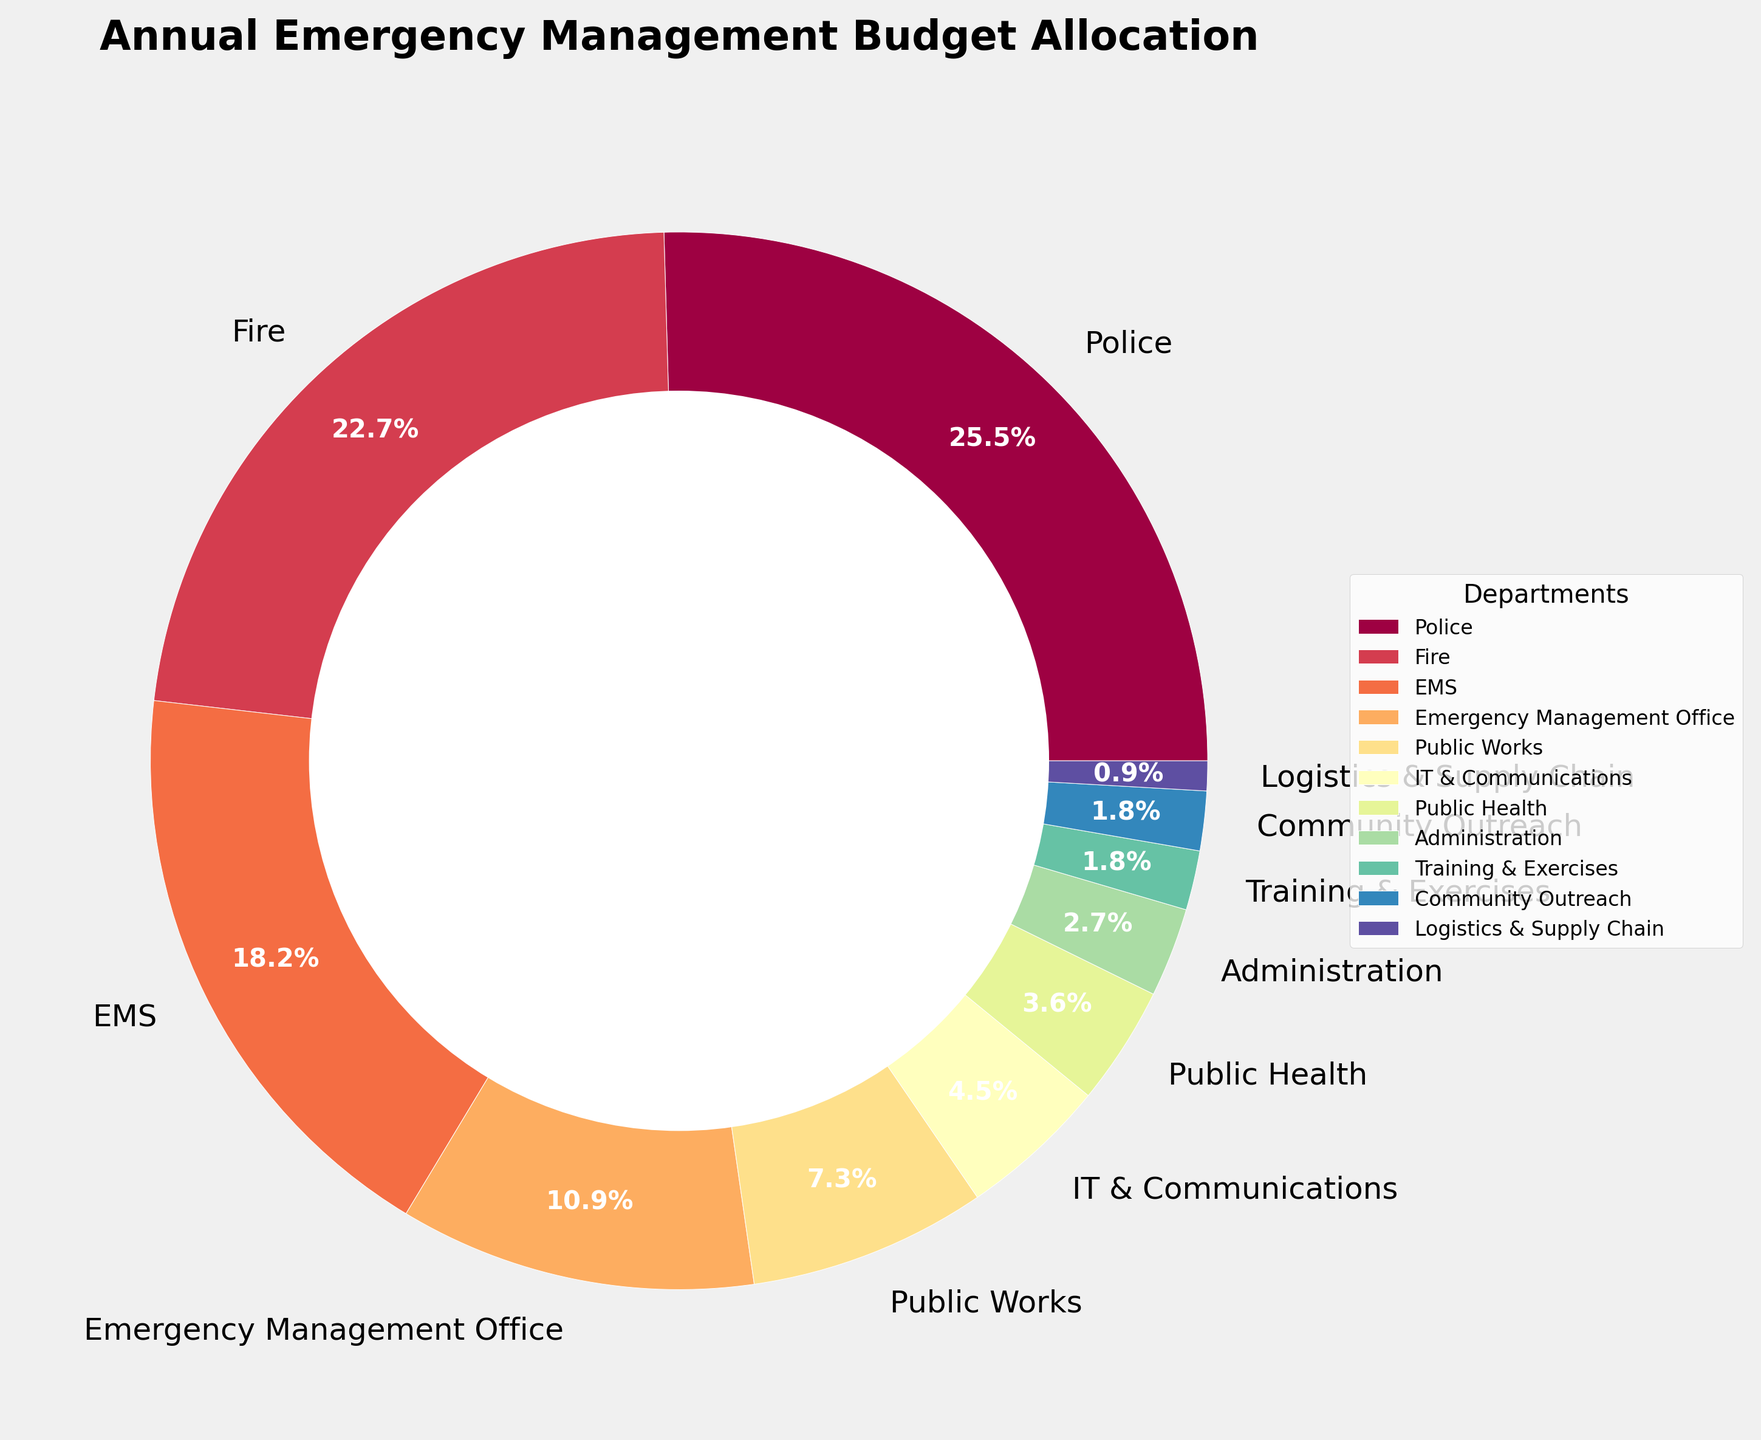Which department receives the highest allocation? By observing the pie chart, the Police department occupies the largest segment.
Answer: Police Which department receives the smallest allocation? From the pie chart, the Logistics & Supply Chain department is represented by the smallest segment.
Answer: Logistics & Supply Chain What is the combined budget allocation of the top three departments? The top three departments are Police (28%), Fire (25%), and EMS (20%). Adding these gives 28 + 25 + 20 = 73%.
Answer: 73% Is the budget allocation for EMS greater than that for the Emergency Management Office? Yes. By comparing their segments, EMS has 20% whereas the Emergency Management Office has 12%.
Answer: Yes Which departments collectively make up less than 10% of the budget allocation? Training & Exercises (2%), Community Outreach (2%), Logistics & Supply Chain (1%) and Public Health (4%) collectively add up to 2 + 2 + 1 + 4 = 9%.
Answer: Training & Exercises, Community Outreach, Logistics & Supply Chain, Public Health What percentage of the budget is allocated to departments other than Police, Fire, and EMS? The sum of the large three is 73%. Therefore, the remaining percentage is 100% - 73% = 27%.
Answer: 27% How does the budget allocation for Public Works compare with IT & Communications? Public Works has 8% allocation while IT & Communications has 5%. Hence, Public Works has a higher allocation.
Answer: Public Works has a higher allocation Which two departments have an equal percentage of budget allocation? There are two departments with 2% each: Training & Exercises and Community Outreach.
Answer: Training & Exercises, Community Outreach What is the difference in budget allocation between Fire and EMS? Fire has 25% and EMS has 20%. The difference is 25% - 20% = 5%.
Answer: 5% How much larger is the budget allocation for the Emergency Management Office compared to Administration? The Emergency Management Office has 12% while Administration has 3%. The difference is 12% - 3% = 9%.
Answer: 9% 